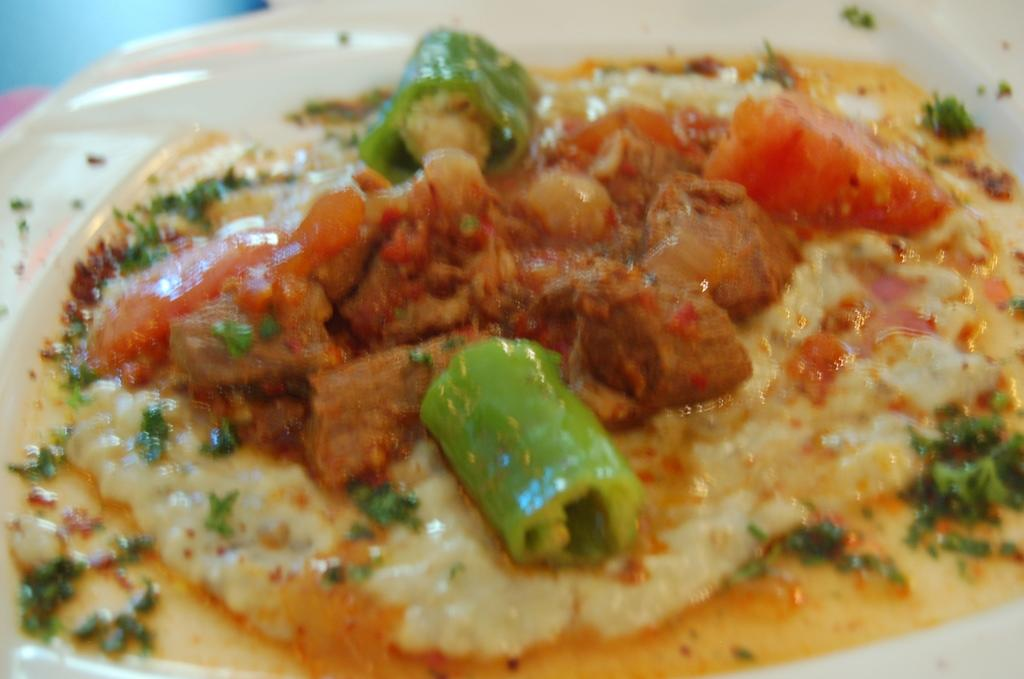What is present on the plate in the image? There is a plate containing food in the image. Can you describe the type of food on the plate? The provided facts do not specify the type of food on the plate. Is there any utensil or additional item present with the plate? The provided facts do not mention any utensil or additional item. What type of board is visible in the image? There is no board present in the image; it only contains a plate with food. How many hearts can be seen in the image? There are no hearts visible in the image; it only contains a plate with food. 